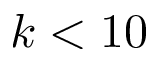<formula> <loc_0><loc_0><loc_500><loc_500>k < 1 0</formula> 